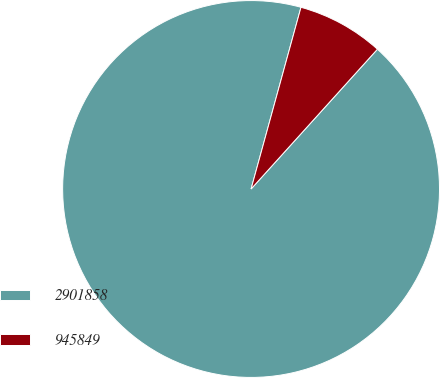Convert chart to OTSL. <chart><loc_0><loc_0><loc_500><loc_500><pie_chart><fcel>2901858<fcel>945849<nl><fcel>92.57%<fcel>7.43%<nl></chart> 